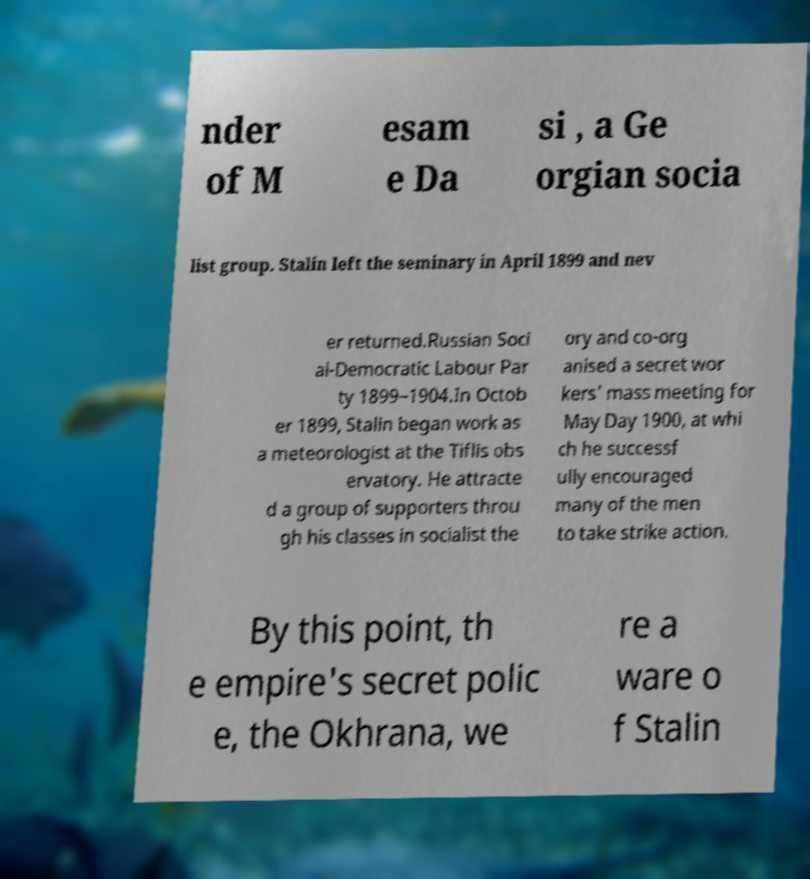What messages or text are displayed in this image? I need them in a readable, typed format. nder of M esam e Da si , a Ge orgian socia list group. Stalin left the seminary in April 1899 and nev er returned.Russian Soci al-Democratic Labour Par ty 1899–1904.In Octob er 1899, Stalin began work as a meteorologist at the Tiflis obs ervatory. He attracte d a group of supporters throu gh his classes in socialist the ory and co-org anised a secret wor kers' mass meeting for May Day 1900, at whi ch he successf ully encouraged many of the men to take strike action. By this point, th e empire's secret polic e, the Okhrana, we re a ware o f Stalin 